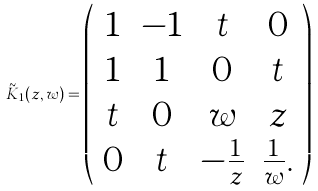<formula> <loc_0><loc_0><loc_500><loc_500>\tilde { K } _ { 1 } ( z , w ) = \left ( \begin{array} { c c c c } 1 & - 1 & t & 0 \\ 1 & 1 & 0 & t \\ t & 0 & w & z \\ 0 & t & - \frac { 1 } { z } & \frac { 1 } { w } . \end{array} \right )</formula> 